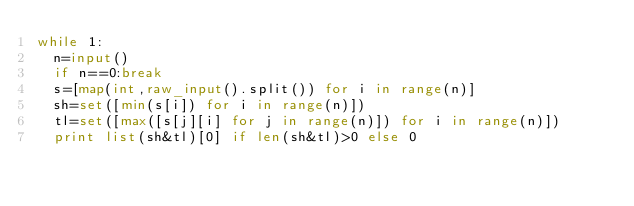<code> <loc_0><loc_0><loc_500><loc_500><_Python_>while 1:
	n=input()
	if n==0:break
	s=[map(int,raw_input().split()) for i in range(n)]
	sh=set([min(s[i]) for i in range(n)])
	tl=set([max([s[j][i] for j in range(n)]) for i in range(n)])
	print list(sh&tl)[0] if len(sh&tl)>0 else 0
	</code> 